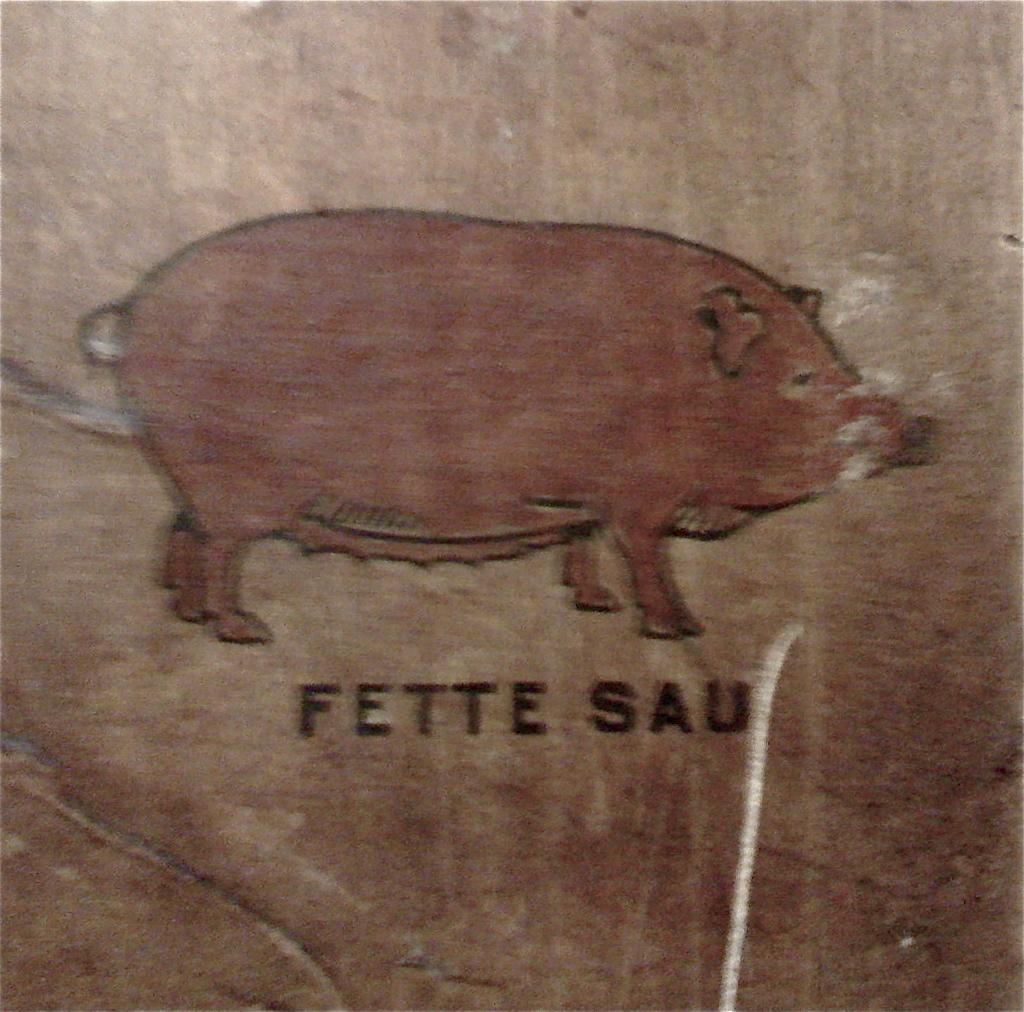What is depicted in the image? There is a drawing of a pig in the image. Where is the drawing located? The drawing is on a platform. What type of game is the pig playing in the image? There is no game or indication of play in the image; it only features a drawing of a pig on a platform. 